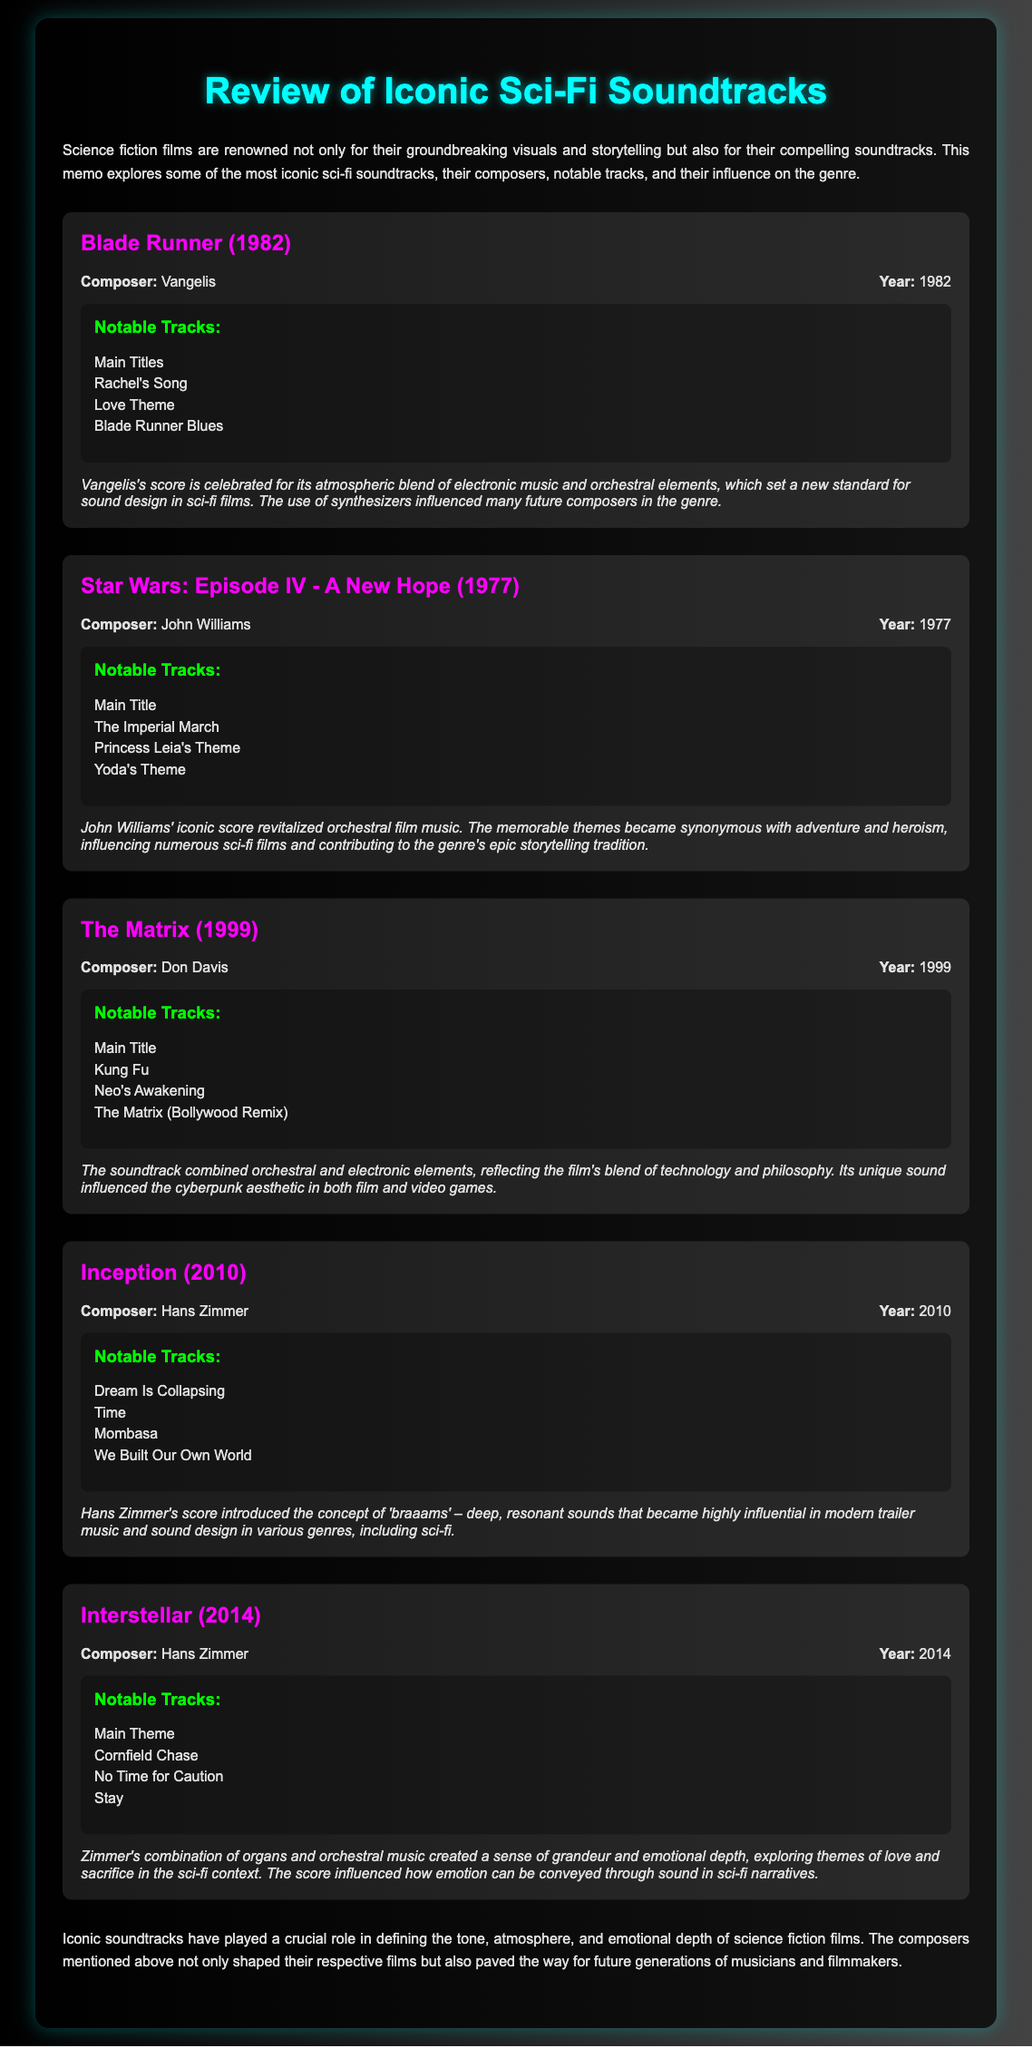What is the title of the memo? The title of the memo is explicitly stated at the beginning of the document.
Answer: Review of Iconic Sci-Fi Soundtracks Who composed the soundtrack for Blade Runner? The document provides the composer name associated with each soundtrack.
Answer: Vangelis What year was Star Wars: Episode IV - A New Hope released? The release year is mentioned in the information for the soundtrack.
Answer: 1977 Which tracks are notable in The Matrix? The notable tracks for each soundtrack are listed in the document.
Answer: Main Title, Kung Fu, Neo's Awakening, The Matrix (Bollywood Remix) What influence did Vangelis' score have on the genre? The document discusses the influence of each composer’s score on the genre.
Answer: Set a new standard for sound design in sci-fi films Which composer created 'braaams'? The document indicates which composer is known for this significant sound in modern trailer music.
Answer: Hans Zimmer How many notable tracks are listed for Inception? The number of notable tracks is determined by counting the items listed for that soundtrack.
Answer: 4 What is a notable theme in Interstellar's soundtrack? The document highlights notable themes associated with each soundtrack's emotional context.
Answer: Love and sacrifice What color is used for the heading of each soundtrack? Color choice is mentioned in the styling of the document regarding the soundtrack titles.
Answer: Magenta 